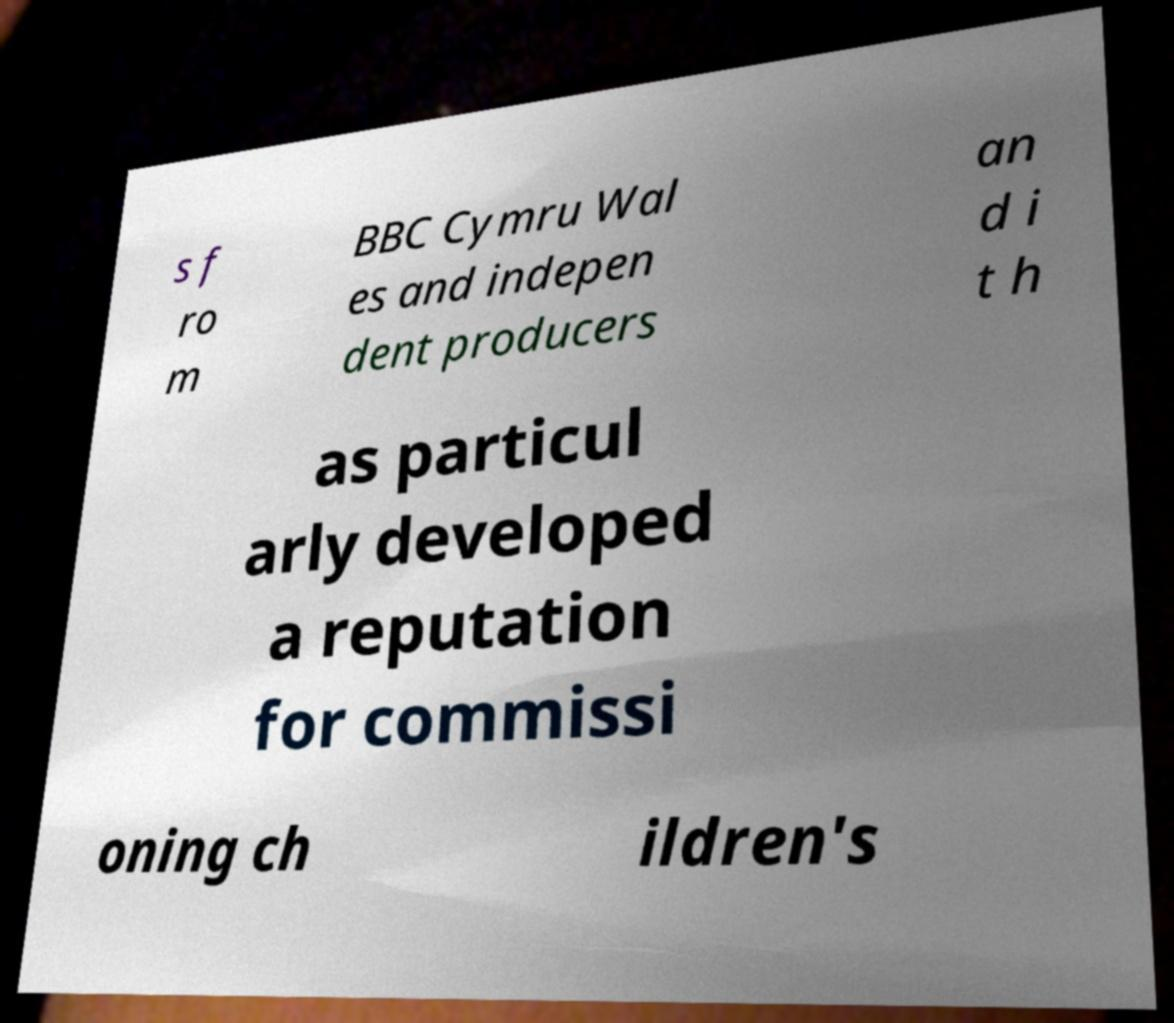Can you accurately transcribe the text from the provided image for me? s f ro m BBC Cymru Wal es and indepen dent producers an d i t h as particul arly developed a reputation for commissi oning ch ildren's 